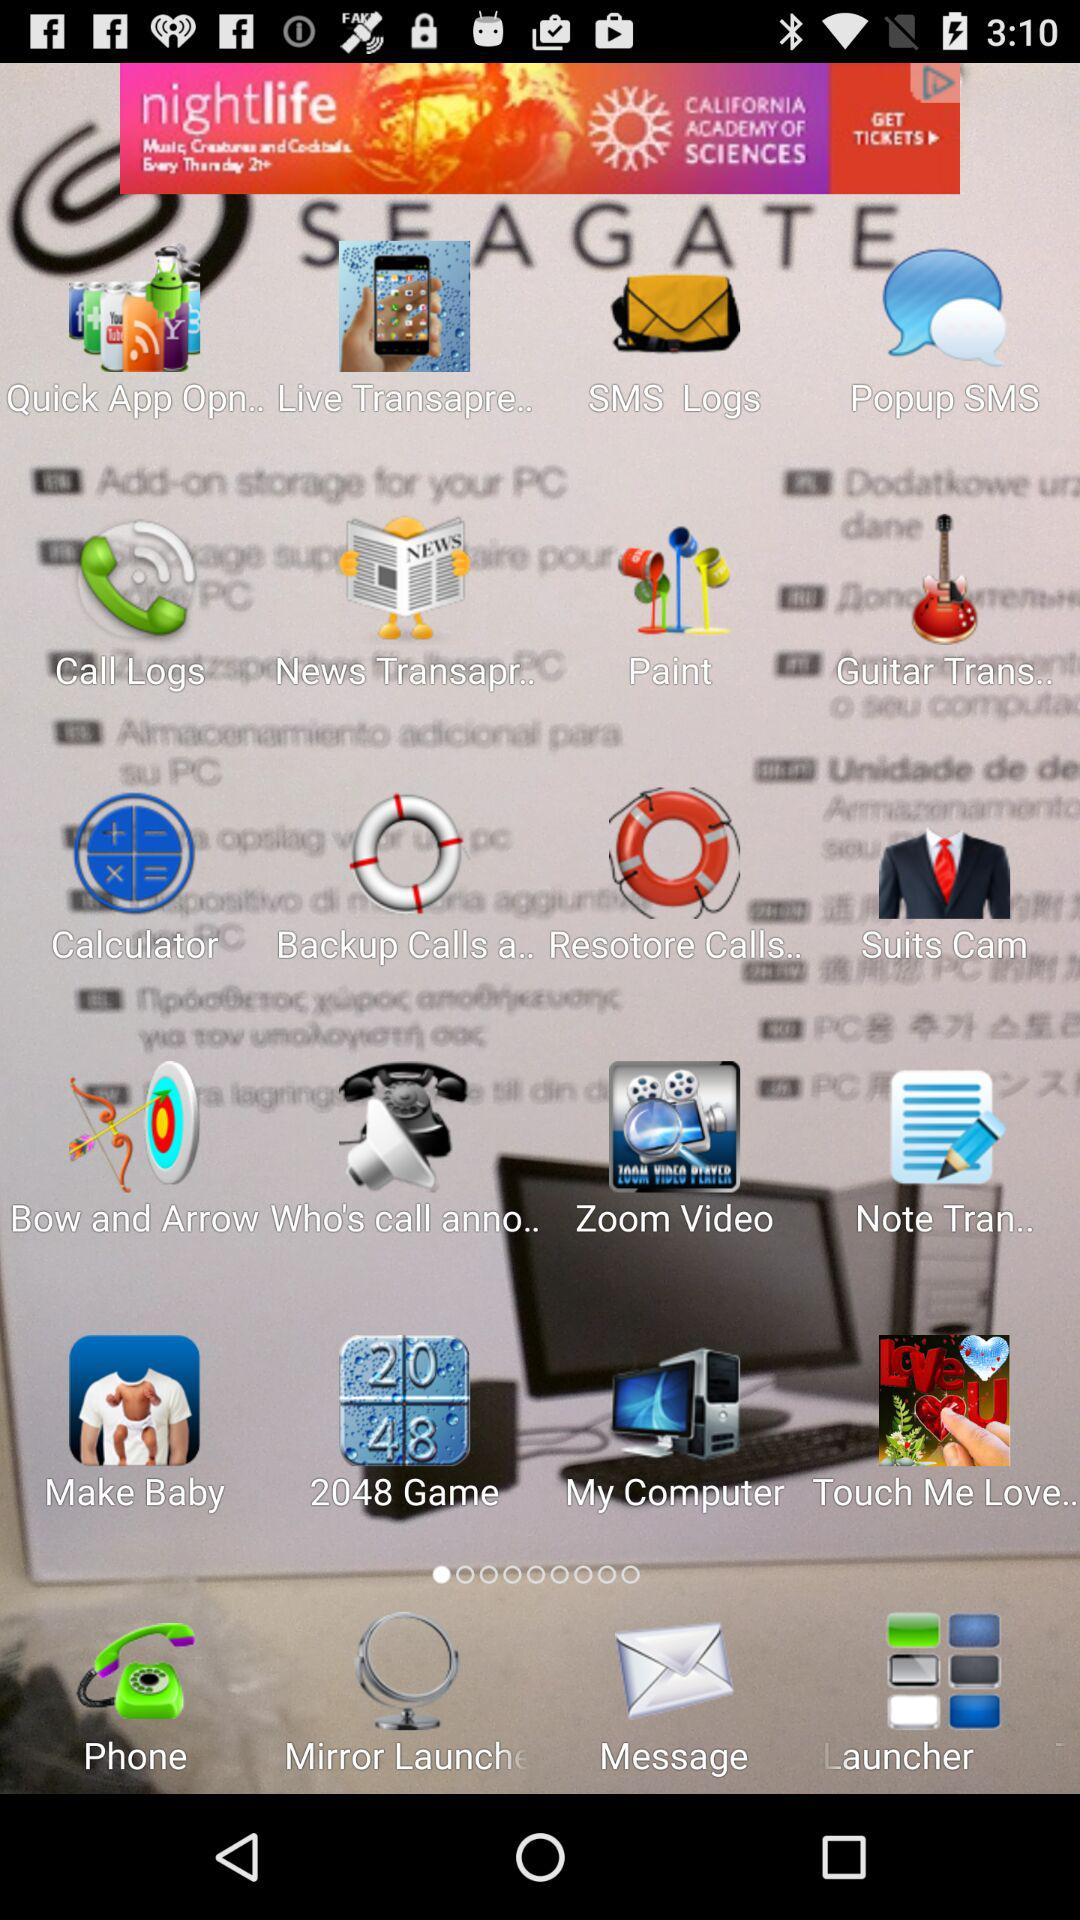What is the app name? The app name is "Transparent Screen Launcher". 